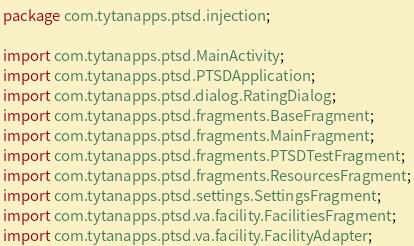Convert code to text. <code><loc_0><loc_0><loc_500><loc_500><_Java_>package com.tytanapps.ptsd.injection;

import com.tytanapps.ptsd.MainActivity;
import com.tytanapps.ptsd.PTSDApplication;
import com.tytanapps.ptsd.dialog.RatingDialog;
import com.tytanapps.ptsd.fragments.BaseFragment;
import com.tytanapps.ptsd.fragments.MainFragment;
import com.tytanapps.ptsd.fragments.PTSDTestFragment;
import com.tytanapps.ptsd.fragments.ResourcesFragment;
import com.tytanapps.ptsd.settings.SettingsFragment;
import com.tytanapps.ptsd.va.facility.FacilitiesFragment;
import com.tytanapps.ptsd.va.facility.FacilityAdapter;</code> 